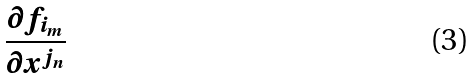Convert formula to latex. <formula><loc_0><loc_0><loc_500><loc_500>\frac { \partial f _ { i _ { m } } } { \partial x ^ { j _ { n } } }</formula> 